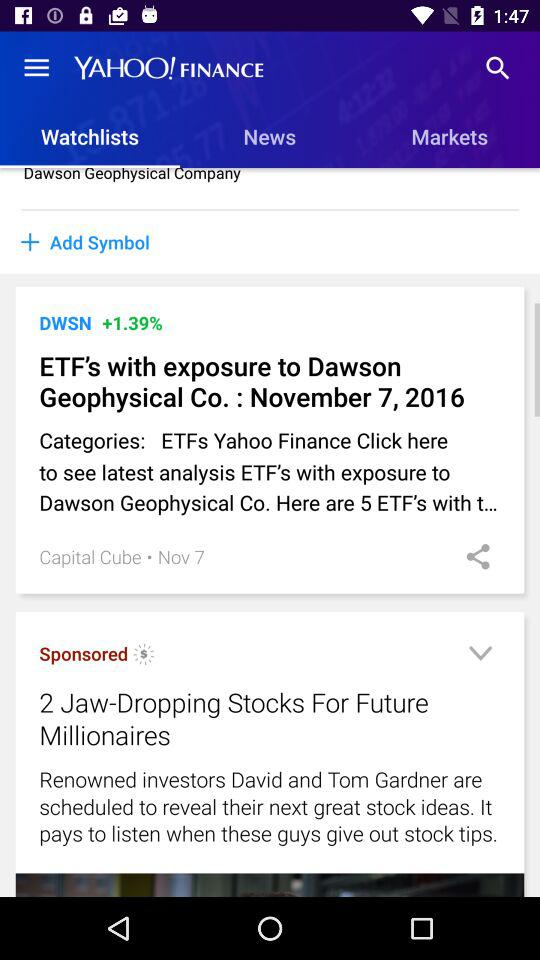What date is mentioned with the title "ETF's with exposure to Dawson"? The mentioned date is November 7, 2016. 